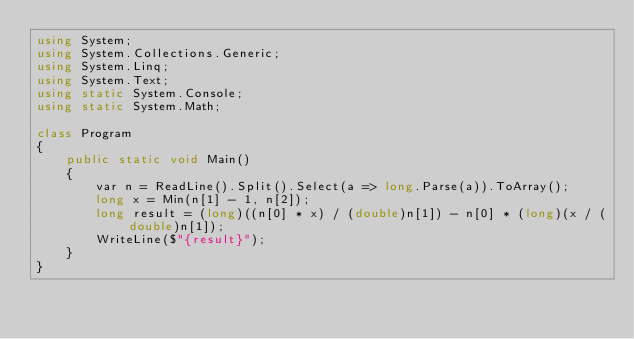<code> <loc_0><loc_0><loc_500><loc_500><_C#_>using System;
using System.Collections.Generic;
using System.Linq;
using System.Text;
using static System.Console;
using static System.Math;

class Program
{
    public static void Main()
    {
        var n = ReadLine().Split().Select(a => long.Parse(a)).ToArray();
        long x = Min(n[1] - 1, n[2]);
        long result = (long)((n[0] * x) / (double)n[1]) - n[0] * (long)(x / (double)n[1]);
        WriteLine($"{result}");
    }
}
</code> 